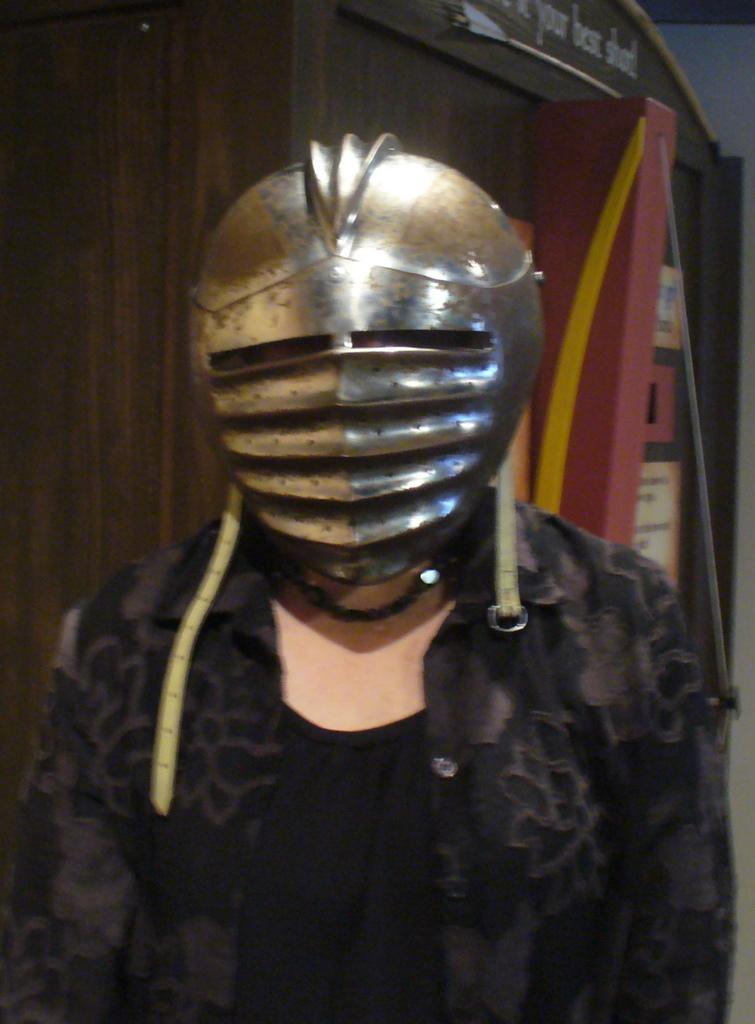Could you give a brief overview of what you see in this image? In this picture, we see a woman in the black dress is wearing the knight helmet. Behind her, we see a pole or a pillar in red and yellow color. On the left side, we see a brown wall. In the background, we see a white wall. At the top, we see some text written on it. 